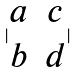<formula> <loc_0><loc_0><loc_500><loc_500>| \begin{matrix} a & c \\ b & d \end{matrix} |</formula> 